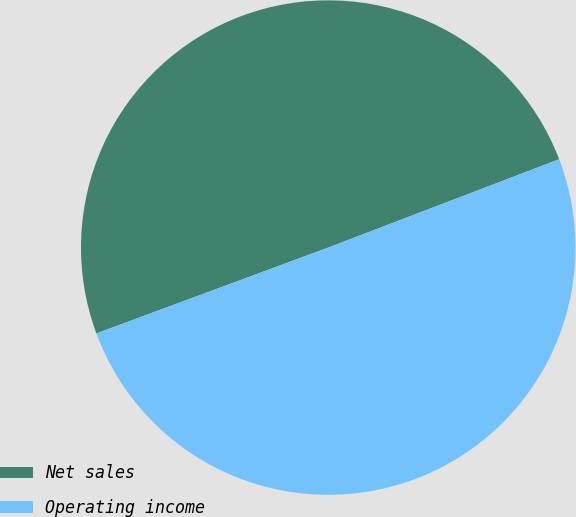<chart> <loc_0><loc_0><loc_500><loc_500><pie_chart><fcel>Net sales<fcel>Operating income<nl><fcel>49.83%<fcel>50.17%<nl></chart> 